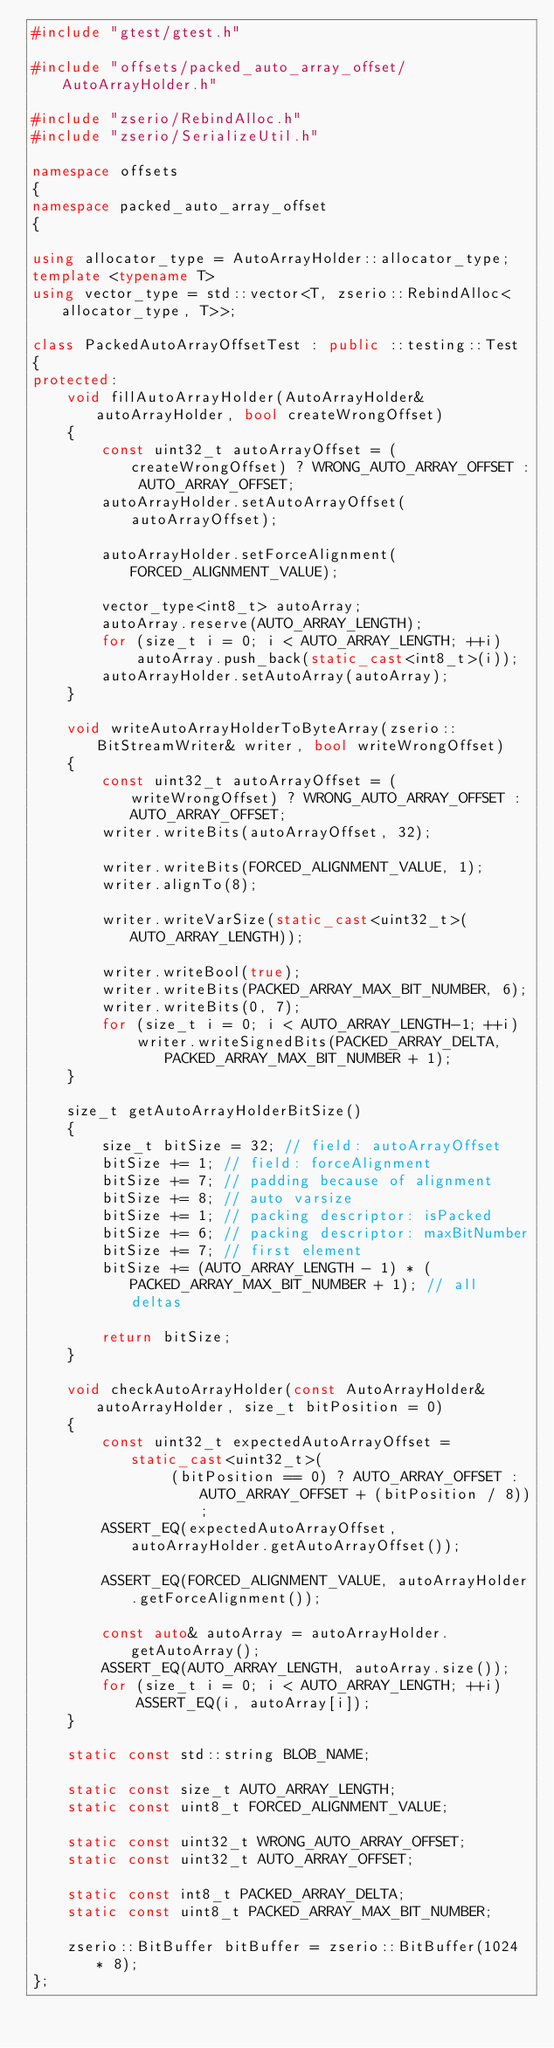<code> <loc_0><loc_0><loc_500><loc_500><_C++_>#include "gtest/gtest.h"

#include "offsets/packed_auto_array_offset/AutoArrayHolder.h"

#include "zserio/RebindAlloc.h"
#include "zserio/SerializeUtil.h"

namespace offsets
{
namespace packed_auto_array_offset
{

using allocator_type = AutoArrayHolder::allocator_type;
template <typename T>
using vector_type = std::vector<T, zserio::RebindAlloc<allocator_type, T>>;

class PackedAutoArrayOffsetTest : public ::testing::Test
{
protected:
    void fillAutoArrayHolder(AutoArrayHolder& autoArrayHolder, bool createWrongOffset)
    {
        const uint32_t autoArrayOffset = (createWrongOffset) ? WRONG_AUTO_ARRAY_OFFSET : AUTO_ARRAY_OFFSET;
        autoArrayHolder.setAutoArrayOffset(autoArrayOffset);

        autoArrayHolder.setForceAlignment(FORCED_ALIGNMENT_VALUE);

        vector_type<int8_t> autoArray;
        autoArray.reserve(AUTO_ARRAY_LENGTH);
        for (size_t i = 0; i < AUTO_ARRAY_LENGTH; ++i)
            autoArray.push_back(static_cast<int8_t>(i));
        autoArrayHolder.setAutoArray(autoArray);
    }

    void writeAutoArrayHolderToByteArray(zserio::BitStreamWriter& writer, bool writeWrongOffset)
    {
        const uint32_t autoArrayOffset = (writeWrongOffset) ? WRONG_AUTO_ARRAY_OFFSET : AUTO_ARRAY_OFFSET;
        writer.writeBits(autoArrayOffset, 32);

        writer.writeBits(FORCED_ALIGNMENT_VALUE, 1);
        writer.alignTo(8);

        writer.writeVarSize(static_cast<uint32_t>(AUTO_ARRAY_LENGTH));

        writer.writeBool(true);
        writer.writeBits(PACKED_ARRAY_MAX_BIT_NUMBER, 6);
        writer.writeBits(0, 7);
        for (size_t i = 0; i < AUTO_ARRAY_LENGTH-1; ++i)
            writer.writeSignedBits(PACKED_ARRAY_DELTA, PACKED_ARRAY_MAX_BIT_NUMBER + 1);
    }

    size_t getAutoArrayHolderBitSize()
    {
        size_t bitSize = 32; // field: autoArrayOffset
        bitSize += 1; // field: forceAlignment
        bitSize += 7; // padding because of alignment
        bitSize += 8; // auto varsize
        bitSize += 1; // packing descriptor: isPacked
        bitSize += 6; // packing descriptor: maxBitNumber
        bitSize += 7; // first element
        bitSize += (AUTO_ARRAY_LENGTH - 1) * (PACKED_ARRAY_MAX_BIT_NUMBER + 1); // all deltas

        return bitSize;
    }

    void checkAutoArrayHolder(const AutoArrayHolder& autoArrayHolder, size_t bitPosition = 0)
    {
        const uint32_t expectedAutoArrayOffset = static_cast<uint32_t>(
                (bitPosition == 0) ? AUTO_ARRAY_OFFSET : AUTO_ARRAY_OFFSET + (bitPosition / 8));
        ASSERT_EQ(expectedAutoArrayOffset, autoArrayHolder.getAutoArrayOffset());

        ASSERT_EQ(FORCED_ALIGNMENT_VALUE, autoArrayHolder.getForceAlignment());

        const auto& autoArray = autoArrayHolder.getAutoArray();
        ASSERT_EQ(AUTO_ARRAY_LENGTH, autoArray.size());
        for (size_t i = 0; i < AUTO_ARRAY_LENGTH; ++i)
            ASSERT_EQ(i, autoArray[i]);
    }

    static const std::string BLOB_NAME;

    static const size_t AUTO_ARRAY_LENGTH;
    static const uint8_t FORCED_ALIGNMENT_VALUE;

    static const uint32_t WRONG_AUTO_ARRAY_OFFSET;
    static const uint32_t AUTO_ARRAY_OFFSET;

    static const int8_t PACKED_ARRAY_DELTA;
    static const uint8_t PACKED_ARRAY_MAX_BIT_NUMBER;

    zserio::BitBuffer bitBuffer = zserio::BitBuffer(1024 * 8);
};
</code> 